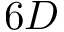Convert formula to latex. <formula><loc_0><loc_0><loc_500><loc_500>6 D</formula> 